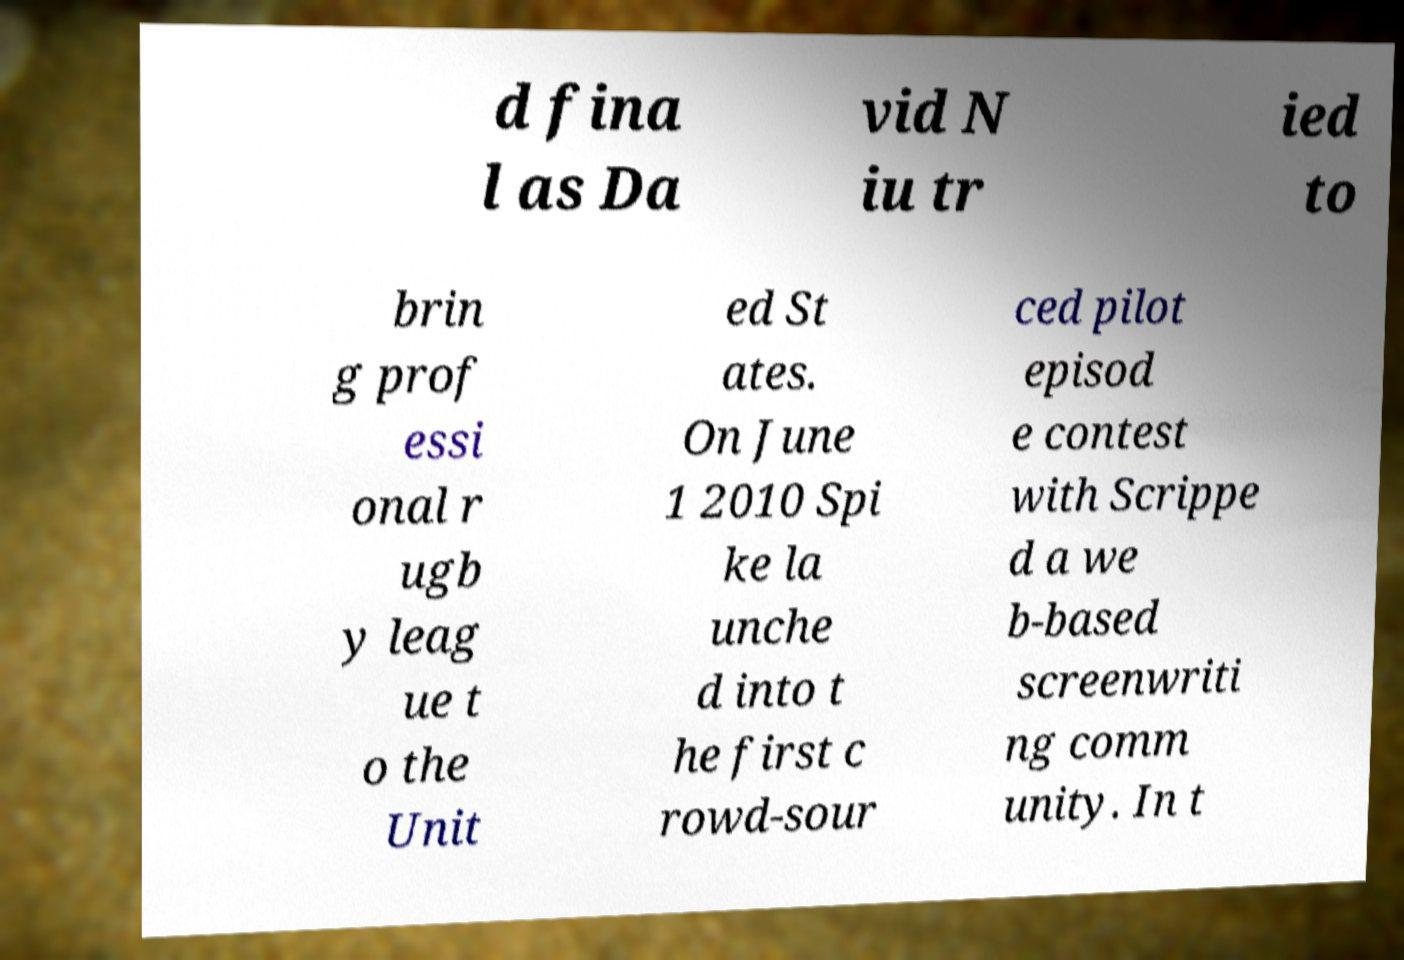There's text embedded in this image that I need extracted. Can you transcribe it verbatim? d fina l as Da vid N iu tr ied to brin g prof essi onal r ugb y leag ue t o the Unit ed St ates. On June 1 2010 Spi ke la unche d into t he first c rowd-sour ced pilot episod e contest with Scrippe d a we b-based screenwriti ng comm unity. In t 